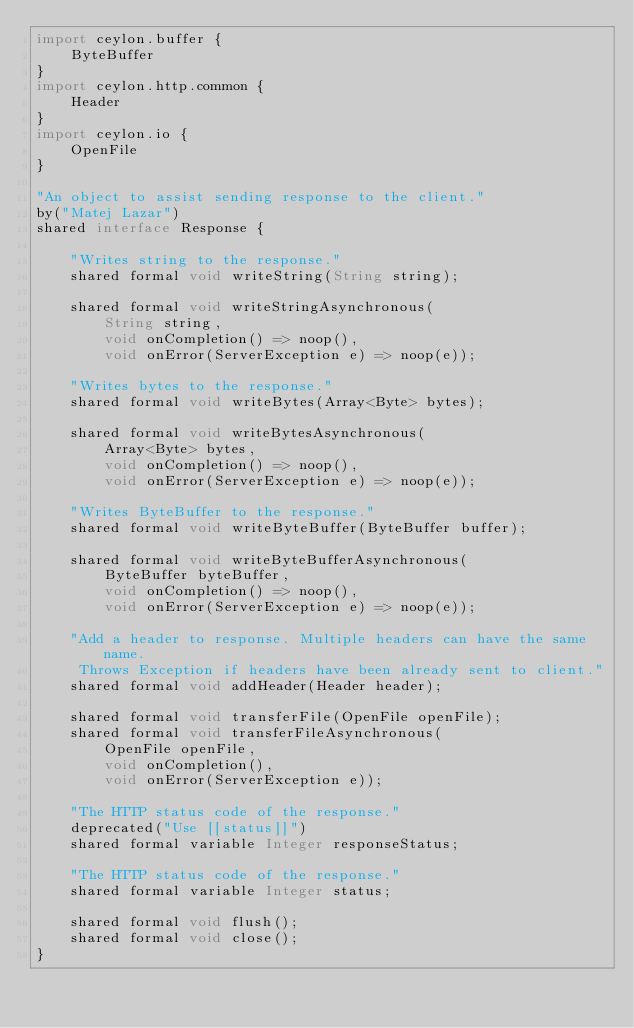<code> <loc_0><loc_0><loc_500><loc_500><_Ceylon_>import ceylon.buffer {
    ByteBuffer
}
import ceylon.http.common {
    Header
}
import ceylon.io {
    OpenFile
}

"An object to assist sending response to the client."
by("Matej Lazar")
shared interface Response {

    "Writes string to the response."
    shared formal void writeString(String string);

    shared formal void writeStringAsynchronous(
        String string, 
        void onCompletion() => noop(),
        void onError(ServerException e) => noop(e));

    "Writes bytes to the response."
    shared formal void writeBytes(Array<Byte> bytes);

    shared formal void writeBytesAsynchronous(
        Array<Byte> bytes,
        void onCompletion() => noop(),
        void onError(ServerException e) => noop(e));

    "Writes ByteBuffer to the response."
    shared formal void writeByteBuffer(ByteBuffer buffer);

    shared formal void writeByteBufferAsynchronous(
        ByteBuffer byteBuffer,
        void onCompletion() => noop(),
        void onError(ServerException e) => noop(e));

    "Add a header to response. Multiple headers can have the same name.
     Throws Exception if headers have been already sent to client."
    shared formal void addHeader(Header header);

    shared formal void transferFile(OpenFile openFile);
    shared formal void transferFileAsynchronous(
        OpenFile openFile,
        void onCompletion(),
        void onError(ServerException e));

    "The HTTP status code of the response."
    deprecated("Use [[status]]")
    shared formal variable Integer responseStatus;
    
    "The HTTP status code of the response."
    shared formal variable Integer status;

    shared formal void flush();
    shared formal void close();
}
</code> 